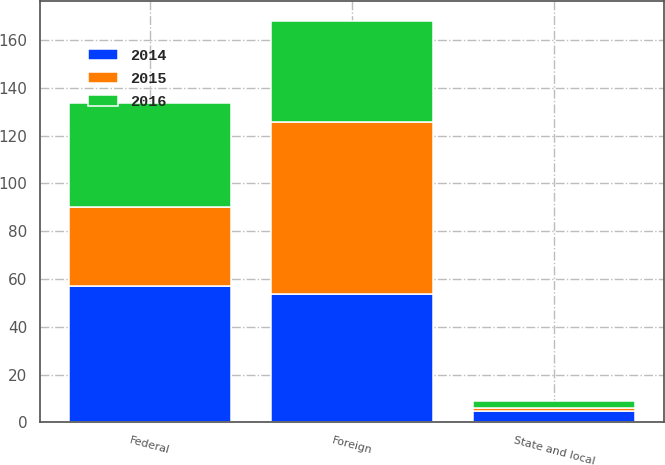<chart> <loc_0><loc_0><loc_500><loc_500><stacked_bar_chart><ecel><fcel>Federal<fcel>State and local<fcel>Foreign<nl><fcel>2016<fcel>43.5<fcel>2.9<fcel>42.1<nl><fcel>2015<fcel>33.2<fcel>1<fcel>71.8<nl><fcel>2014<fcel>57<fcel>4.9<fcel>53.9<nl></chart> 